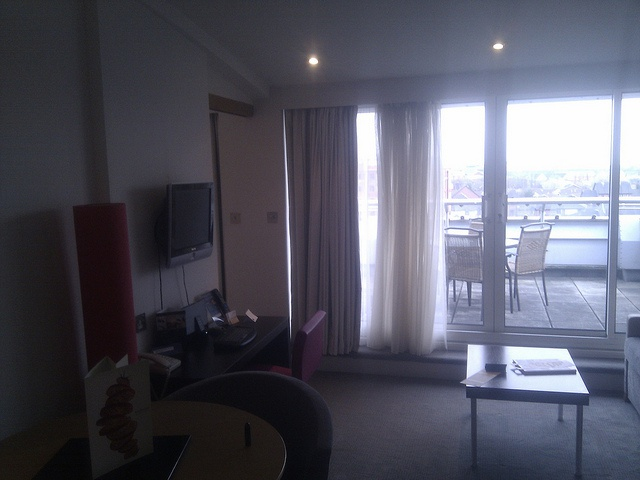Describe the objects in this image and their specific colors. I can see dining table in black tones, chair in black and gray tones, dining table in black, lavender, gray, and navy tones, tv in black tones, and chair in black, gray, darkgray, and lavender tones in this image. 